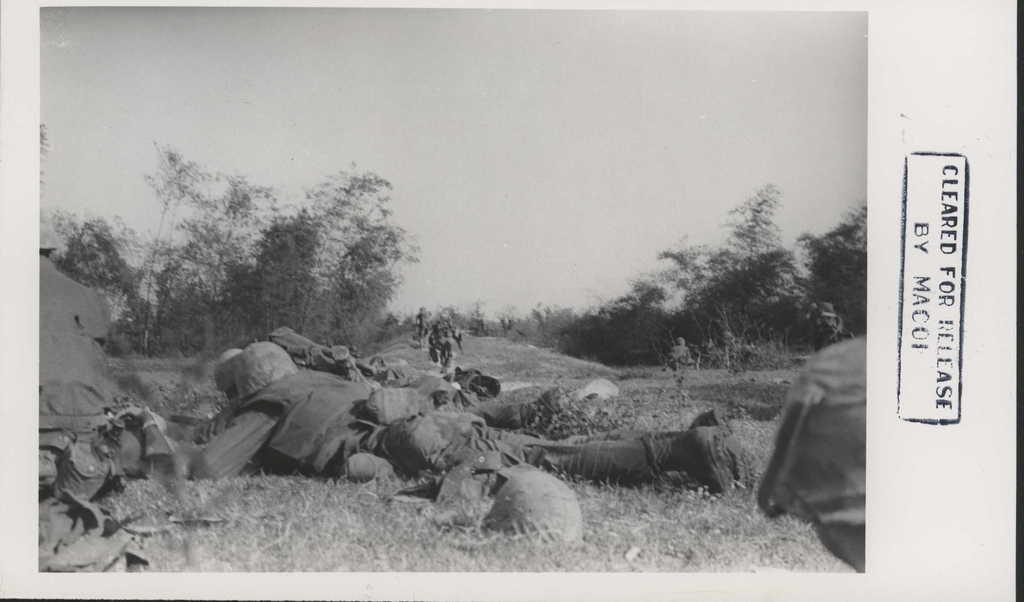What are the soldiers in the image doing? The soldiers are lying on the ground in the image. What can be seen in the background of the image? There are trees and sky visible in the background of the image. Where is the text located in the image? The text is on the right side of the image. What type of wool is being used by the farmer in the image? There is no farmer or wool present in the image; it features soldiers lying on the ground. How many cars can be seen in the image? There are no cars visible in the image. 